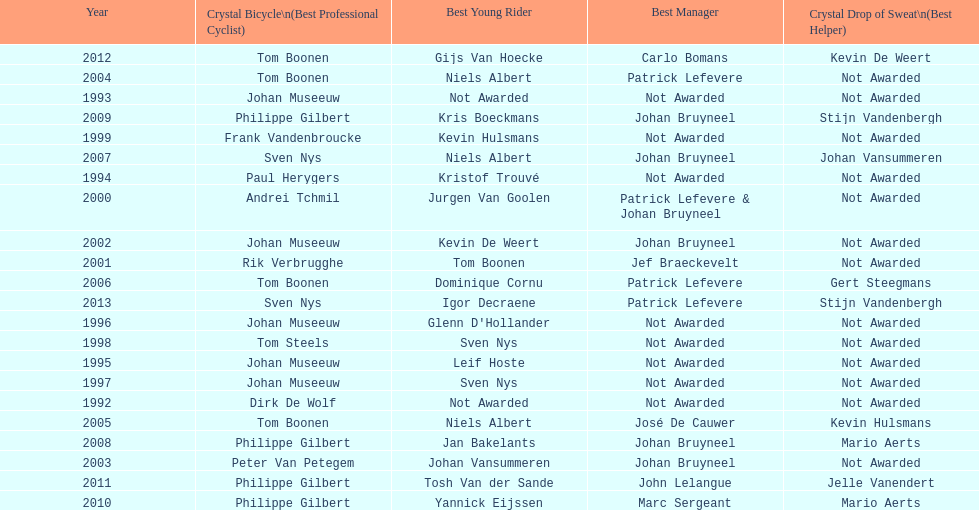Who won the crystal bicycle earlier, boonen or nys? Tom Boonen. Could you parse the entire table? {'header': ['Year', 'Crystal Bicycle\\n(Best Professional Cyclist)', 'Best Young Rider', 'Best Manager', 'Crystal Drop of Sweat\\n(Best Helper)'], 'rows': [['2012', 'Tom Boonen', 'Gijs Van Hoecke', 'Carlo Bomans', 'Kevin De Weert'], ['2004', 'Tom Boonen', 'Niels Albert', 'Patrick Lefevere', 'Not Awarded'], ['1993', 'Johan Museeuw', 'Not Awarded', 'Not Awarded', 'Not Awarded'], ['2009', 'Philippe Gilbert', 'Kris Boeckmans', 'Johan Bruyneel', 'Stijn Vandenbergh'], ['1999', 'Frank Vandenbroucke', 'Kevin Hulsmans', 'Not Awarded', 'Not Awarded'], ['2007', 'Sven Nys', 'Niels Albert', 'Johan Bruyneel', 'Johan Vansummeren'], ['1994', 'Paul Herygers', 'Kristof Trouvé', 'Not Awarded', 'Not Awarded'], ['2000', 'Andrei Tchmil', 'Jurgen Van Goolen', 'Patrick Lefevere & Johan Bruyneel', 'Not Awarded'], ['2002', 'Johan Museeuw', 'Kevin De Weert', 'Johan Bruyneel', 'Not Awarded'], ['2001', 'Rik Verbrugghe', 'Tom Boonen', 'Jef Braeckevelt', 'Not Awarded'], ['2006', 'Tom Boonen', 'Dominique Cornu', 'Patrick Lefevere', 'Gert Steegmans'], ['2013', 'Sven Nys', 'Igor Decraene', 'Patrick Lefevere', 'Stijn Vandenbergh'], ['1996', 'Johan Museeuw', "Glenn D'Hollander", 'Not Awarded', 'Not Awarded'], ['1998', 'Tom Steels', 'Sven Nys', 'Not Awarded', 'Not Awarded'], ['1995', 'Johan Museeuw', 'Leif Hoste', 'Not Awarded', 'Not Awarded'], ['1997', 'Johan Museeuw', 'Sven Nys', 'Not Awarded', 'Not Awarded'], ['1992', 'Dirk De Wolf', 'Not Awarded', 'Not Awarded', 'Not Awarded'], ['2005', 'Tom Boonen', 'Niels Albert', 'José De Cauwer', 'Kevin Hulsmans'], ['2008', 'Philippe Gilbert', 'Jan Bakelants', 'Johan Bruyneel', 'Mario Aerts'], ['2003', 'Peter Van Petegem', 'Johan Vansummeren', 'Johan Bruyneel', 'Not Awarded'], ['2011', 'Philippe Gilbert', 'Tosh Van der Sande', 'John Lelangue', 'Jelle Vanendert'], ['2010', 'Philippe Gilbert', 'Yannick Eijssen', 'Marc Sergeant', 'Mario Aerts']]} 